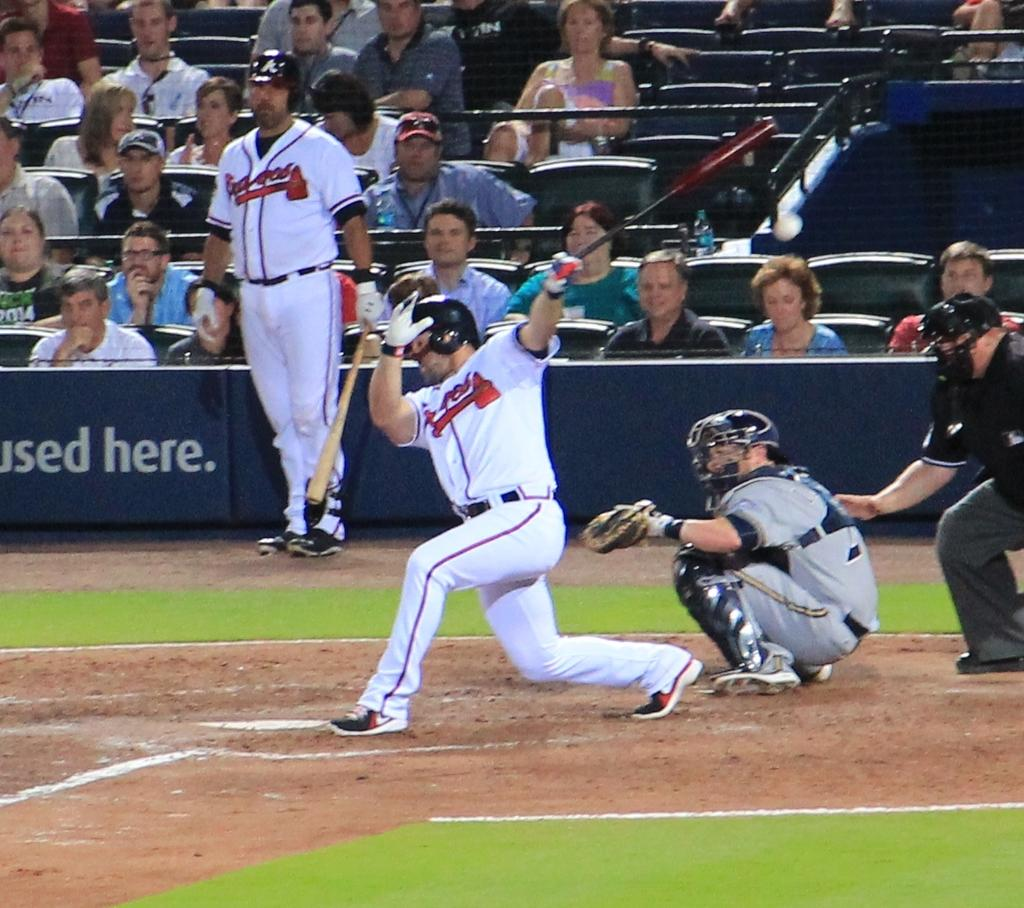<image>
Present a compact description of the photo's key features. Two players in Braves baseball uniforms at a baseball game. 